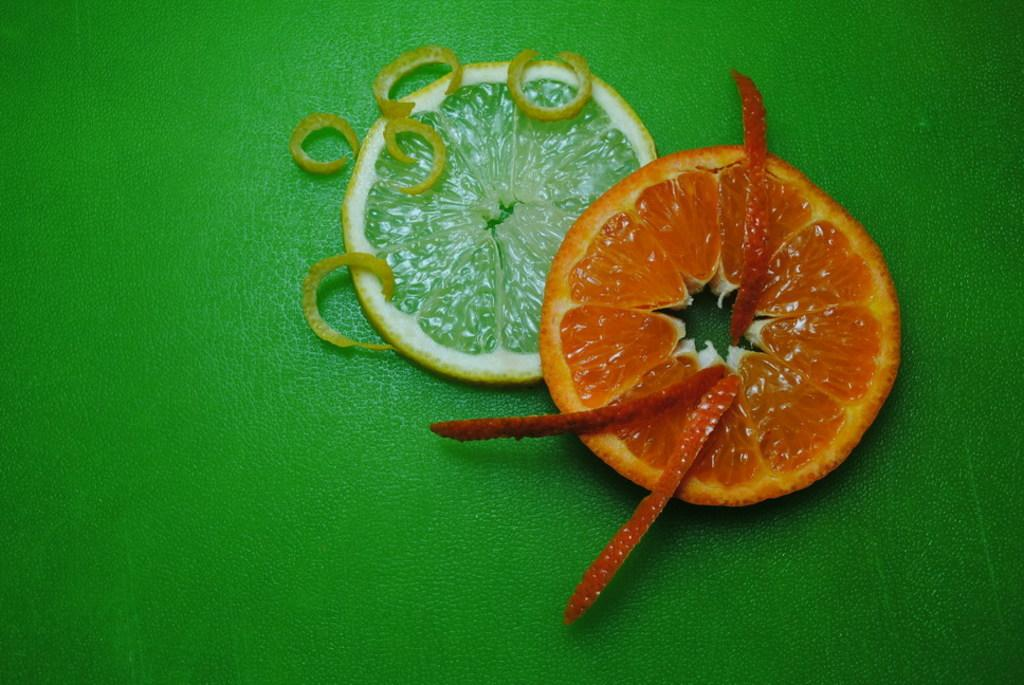What type of fruit is visible in the image? There is a slice of orange and a lemon in the image. What part of the orange is also present in the image? There is a peel of orange in the image. Where are all the items located in the image? All items are on a table. What book is the beggar reading in the image? There is no book or beggar present in the image; it only features a slice of orange, a peel of orange, and a lemon on a table. 